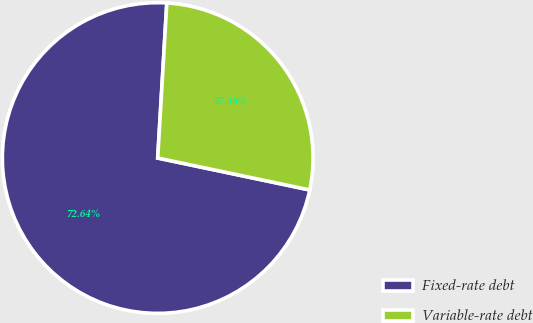Convert chart. <chart><loc_0><loc_0><loc_500><loc_500><pie_chart><fcel>Fixed-rate debt<fcel>Variable-rate debt<nl><fcel>72.64%<fcel>27.36%<nl></chart> 